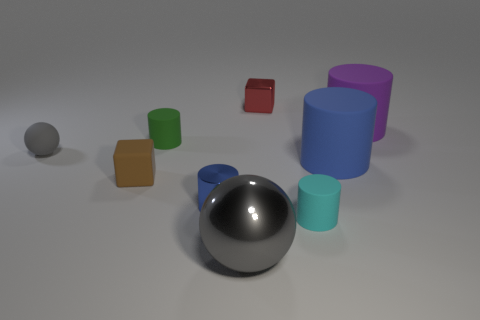What is the shape of the large rubber thing in front of the gray object that is to the left of the big gray sphere?
Offer a terse response. Cylinder. What size is the green rubber object that is to the right of the cube that is left of the cube behind the big purple matte cylinder?
Provide a short and direct response. Small. The other tiny matte object that is the same shape as the tiny red object is what color?
Keep it short and to the point. Brown. Is the cyan matte object the same size as the matte block?
Ensure brevity in your answer.  Yes. There is a blue thing behind the brown thing; what material is it?
Keep it short and to the point. Rubber. What number of other objects are the same shape as the small gray object?
Ensure brevity in your answer.  1. Does the gray shiny object have the same shape as the small green object?
Your response must be concise. No. Are there any tiny spheres in front of the big blue object?
Offer a very short reply. No. How many objects are either large yellow matte cylinders or blue things?
Your response must be concise. 2. How many other things are the same size as the blue rubber thing?
Give a very brief answer. 2. 